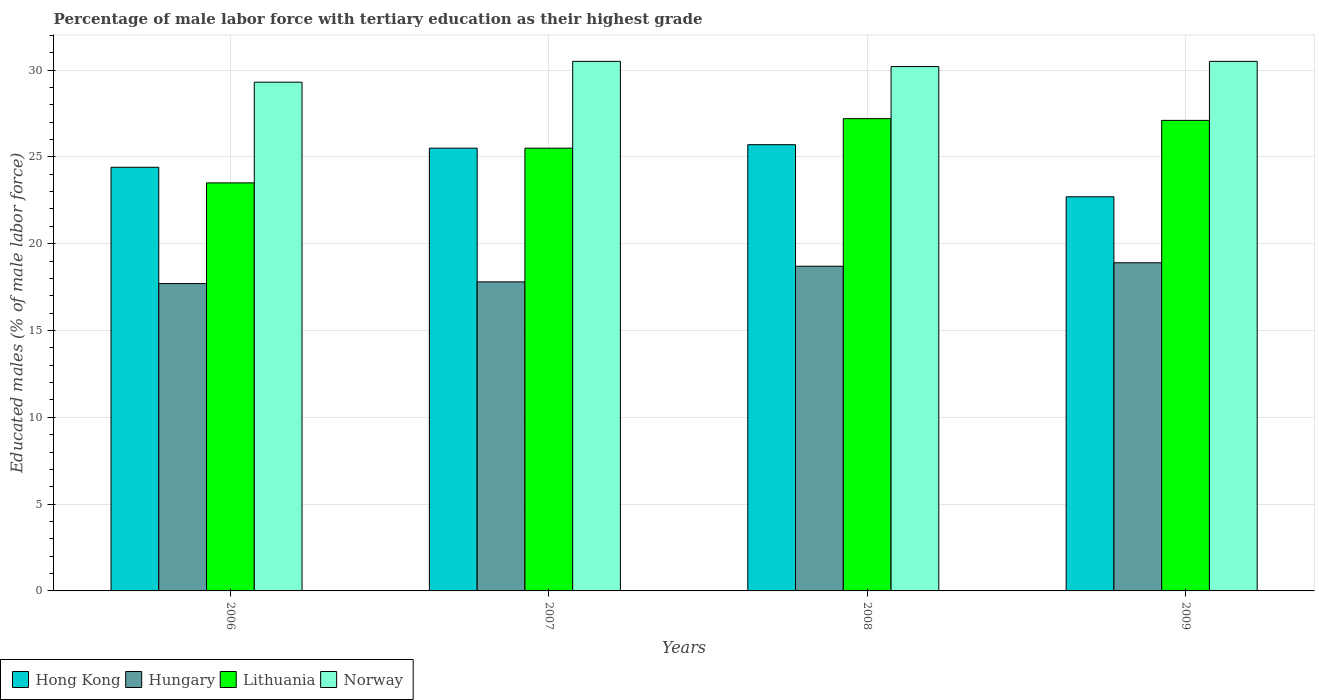How many groups of bars are there?
Offer a terse response. 4. Are the number of bars per tick equal to the number of legend labels?
Make the answer very short. Yes. How many bars are there on the 2nd tick from the left?
Give a very brief answer. 4. How many bars are there on the 3rd tick from the right?
Offer a very short reply. 4. What is the label of the 3rd group of bars from the left?
Make the answer very short. 2008. What is the percentage of male labor force with tertiary education in Hungary in 2006?
Keep it short and to the point. 17.7. Across all years, what is the maximum percentage of male labor force with tertiary education in Lithuania?
Your answer should be compact. 27.2. Across all years, what is the minimum percentage of male labor force with tertiary education in Norway?
Provide a succinct answer. 29.3. What is the total percentage of male labor force with tertiary education in Hong Kong in the graph?
Keep it short and to the point. 98.3. What is the difference between the percentage of male labor force with tertiary education in Lithuania in 2006 and that in 2009?
Your answer should be very brief. -3.6. What is the difference between the percentage of male labor force with tertiary education in Lithuania in 2008 and the percentage of male labor force with tertiary education in Hungary in 2007?
Your answer should be very brief. 9.4. What is the average percentage of male labor force with tertiary education in Hong Kong per year?
Make the answer very short. 24.58. In the year 2009, what is the difference between the percentage of male labor force with tertiary education in Lithuania and percentage of male labor force with tertiary education in Hungary?
Ensure brevity in your answer.  8.2. In how many years, is the percentage of male labor force with tertiary education in Hungary greater than 24 %?
Your answer should be compact. 0. What is the ratio of the percentage of male labor force with tertiary education in Norway in 2006 to that in 2009?
Your answer should be compact. 0.96. Is the difference between the percentage of male labor force with tertiary education in Lithuania in 2008 and 2009 greater than the difference between the percentage of male labor force with tertiary education in Hungary in 2008 and 2009?
Offer a terse response. Yes. What is the difference between the highest and the second highest percentage of male labor force with tertiary education in Hong Kong?
Make the answer very short. 0.2. What is the difference between the highest and the lowest percentage of male labor force with tertiary education in Lithuania?
Keep it short and to the point. 3.7. In how many years, is the percentage of male labor force with tertiary education in Lithuania greater than the average percentage of male labor force with tertiary education in Lithuania taken over all years?
Your answer should be very brief. 2. What does the 2nd bar from the left in 2007 represents?
Keep it short and to the point. Hungary. How many bars are there?
Your answer should be very brief. 16. How many years are there in the graph?
Provide a succinct answer. 4. Are the values on the major ticks of Y-axis written in scientific E-notation?
Offer a very short reply. No. Does the graph contain any zero values?
Give a very brief answer. No. Does the graph contain grids?
Offer a very short reply. Yes. How are the legend labels stacked?
Give a very brief answer. Horizontal. What is the title of the graph?
Provide a succinct answer. Percentage of male labor force with tertiary education as their highest grade. What is the label or title of the X-axis?
Provide a short and direct response. Years. What is the label or title of the Y-axis?
Make the answer very short. Educated males (% of male labor force). What is the Educated males (% of male labor force) in Hong Kong in 2006?
Your answer should be very brief. 24.4. What is the Educated males (% of male labor force) of Hungary in 2006?
Give a very brief answer. 17.7. What is the Educated males (% of male labor force) of Norway in 2006?
Keep it short and to the point. 29.3. What is the Educated males (% of male labor force) of Hungary in 2007?
Give a very brief answer. 17.8. What is the Educated males (% of male labor force) in Norway in 2007?
Your answer should be compact. 30.5. What is the Educated males (% of male labor force) of Hong Kong in 2008?
Ensure brevity in your answer.  25.7. What is the Educated males (% of male labor force) in Hungary in 2008?
Provide a succinct answer. 18.7. What is the Educated males (% of male labor force) of Lithuania in 2008?
Give a very brief answer. 27.2. What is the Educated males (% of male labor force) in Norway in 2008?
Give a very brief answer. 30.2. What is the Educated males (% of male labor force) of Hong Kong in 2009?
Offer a very short reply. 22.7. What is the Educated males (% of male labor force) of Hungary in 2009?
Provide a succinct answer. 18.9. What is the Educated males (% of male labor force) of Lithuania in 2009?
Give a very brief answer. 27.1. What is the Educated males (% of male labor force) in Norway in 2009?
Your answer should be very brief. 30.5. Across all years, what is the maximum Educated males (% of male labor force) of Hong Kong?
Give a very brief answer. 25.7. Across all years, what is the maximum Educated males (% of male labor force) of Hungary?
Provide a short and direct response. 18.9. Across all years, what is the maximum Educated males (% of male labor force) in Lithuania?
Make the answer very short. 27.2. Across all years, what is the maximum Educated males (% of male labor force) of Norway?
Keep it short and to the point. 30.5. Across all years, what is the minimum Educated males (% of male labor force) in Hong Kong?
Provide a short and direct response. 22.7. Across all years, what is the minimum Educated males (% of male labor force) of Hungary?
Give a very brief answer. 17.7. Across all years, what is the minimum Educated males (% of male labor force) of Norway?
Your response must be concise. 29.3. What is the total Educated males (% of male labor force) in Hong Kong in the graph?
Provide a succinct answer. 98.3. What is the total Educated males (% of male labor force) of Hungary in the graph?
Your answer should be very brief. 73.1. What is the total Educated males (% of male labor force) in Lithuania in the graph?
Offer a very short reply. 103.3. What is the total Educated males (% of male labor force) in Norway in the graph?
Offer a terse response. 120.5. What is the difference between the Educated males (% of male labor force) of Hong Kong in 2006 and that in 2007?
Provide a short and direct response. -1.1. What is the difference between the Educated males (% of male labor force) of Hungary in 2006 and that in 2007?
Keep it short and to the point. -0.1. What is the difference between the Educated males (% of male labor force) in Hong Kong in 2006 and that in 2008?
Make the answer very short. -1.3. What is the difference between the Educated males (% of male labor force) in Hungary in 2006 and that in 2008?
Your answer should be compact. -1. What is the difference between the Educated males (% of male labor force) in Norway in 2006 and that in 2008?
Make the answer very short. -0.9. What is the difference between the Educated males (% of male labor force) in Hong Kong in 2006 and that in 2009?
Your answer should be compact. 1.7. What is the difference between the Educated males (% of male labor force) of Hungary in 2006 and that in 2009?
Your answer should be compact. -1.2. What is the difference between the Educated males (% of male labor force) of Lithuania in 2006 and that in 2009?
Give a very brief answer. -3.6. What is the difference between the Educated males (% of male labor force) of Hong Kong in 2007 and that in 2009?
Give a very brief answer. 2.8. What is the difference between the Educated males (% of male labor force) in Hungary in 2008 and that in 2009?
Offer a very short reply. -0.2. What is the difference between the Educated males (% of male labor force) in Lithuania in 2008 and that in 2009?
Your response must be concise. 0.1. What is the difference between the Educated males (% of male labor force) in Hong Kong in 2006 and the Educated males (% of male labor force) in Lithuania in 2007?
Offer a terse response. -1.1. What is the difference between the Educated males (% of male labor force) of Hungary in 2006 and the Educated males (% of male labor force) of Lithuania in 2007?
Keep it short and to the point. -7.8. What is the difference between the Educated males (% of male labor force) of Hungary in 2006 and the Educated males (% of male labor force) of Norway in 2007?
Provide a short and direct response. -12.8. What is the difference between the Educated males (% of male labor force) of Lithuania in 2006 and the Educated males (% of male labor force) of Norway in 2007?
Make the answer very short. -7. What is the difference between the Educated males (% of male labor force) of Hong Kong in 2006 and the Educated males (% of male labor force) of Norway in 2008?
Provide a succinct answer. -5.8. What is the difference between the Educated males (% of male labor force) of Hungary in 2006 and the Educated males (% of male labor force) of Lithuania in 2008?
Ensure brevity in your answer.  -9.5. What is the difference between the Educated males (% of male labor force) of Hungary in 2006 and the Educated males (% of male labor force) of Norway in 2008?
Your answer should be very brief. -12.5. What is the difference between the Educated males (% of male labor force) of Hong Kong in 2006 and the Educated males (% of male labor force) of Hungary in 2009?
Your response must be concise. 5.5. What is the difference between the Educated males (% of male labor force) in Lithuania in 2006 and the Educated males (% of male labor force) in Norway in 2009?
Provide a short and direct response. -7. What is the difference between the Educated males (% of male labor force) of Hungary in 2007 and the Educated males (% of male labor force) of Lithuania in 2008?
Ensure brevity in your answer.  -9.4. What is the difference between the Educated males (% of male labor force) of Hungary in 2007 and the Educated males (% of male labor force) of Norway in 2008?
Your answer should be very brief. -12.4. What is the difference between the Educated males (% of male labor force) in Hungary in 2007 and the Educated males (% of male labor force) in Lithuania in 2009?
Provide a short and direct response. -9.3. What is the difference between the Educated males (% of male labor force) in Hungary in 2007 and the Educated males (% of male labor force) in Norway in 2009?
Provide a succinct answer. -12.7. What is the difference between the Educated males (% of male labor force) of Hungary in 2008 and the Educated males (% of male labor force) of Lithuania in 2009?
Give a very brief answer. -8.4. What is the difference between the Educated males (% of male labor force) in Hungary in 2008 and the Educated males (% of male labor force) in Norway in 2009?
Keep it short and to the point. -11.8. What is the average Educated males (% of male labor force) in Hong Kong per year?
Your answer should be very brief. 24.57. What is the average Educated males (% of male labor force) in Hungary per year?
Make the answer very short. 18.27. What is the average Educated males (% of male labor force) in Lithuania per year?
Keep it short and to the point. 25.82. What is the average Educated males (% of male labor force) in Norway per year?
Keep it short and to the point. 30.12. In the year 2006, what is the difference between the Educated males (% of male labor force) of Hong Kong and Educated males (% of male labor force) of Hungary?
Ensure brevity in your answer.  6.7. In the year 2006, what is the difference between the Educated males (% of male labor force) in Hong Kong and Educated males (% of male labor force) in Lithuania?
Keep it short and to the point. 0.9. In the year 2006, what is the difference between the Educated males (% of male labor force) in Hong Kong and Educated males (% of male labor force) in Norway?
Provide a succinct answer. -4.9. In the year 2006, what is the difference between the Educated males (% of male labor force) in Hungary and Educated males (% of male labor force) in Lithuania?
Provide a short and direct response. -5.8. In the year 2006, what is the difference between the Educated males (% of male labor force) of Hungary and Educated males (% of male labor force) of Norway?
Keep it short and to the point. -11.6. In the year 2007, what is the difference between the Educated males (% of male labor force) in Hong Kong and Educated males (% of male labor force) in Hungary?
Provide a succinct answer. 7.7. In the year 2007, what is the difference between the Educated males (% of male labor force) in Hong Kong and Educated males (% of male labor force) in Lithuania?
Provide a short and direct response. 0. In the year 2007, what is the difference between the Educated males (% of male labor force) in Hungary and Educated males (% of male labor force) in Lithuania?
Your answer should be compact. -7.7. In the year 2007, what is the difference between the Educated males (% of male labor force) of Hungary and Educated males (% of male labor force) of Norway?
Keep it short and to the point. -12.7. In the year 2007, what is the difference between the Educated males (% of male labor force) of Lithuania and Educated males (% of male labor force) of Norway?
Give a very brief answer. -5. In the year 2008, what is the difference between the Educated males (% of male labor force) of Hong Kong and Educated males (% of male labor force) of Hungary?
Give a very brief answer. 7. In the year 2008, what is the difference between the Educated males (% of male labor force) of Hong Kong and Educated males (% of male labor force) of Norway?
Offer a terse response. -4.5. In the year 2008, what is the difference between the Educated males (% of male labor force) of Hungary and Educated males (% of male labor force) of Norway?
Make the answer very short. -11.5. In the year 2008, what is the difference between the Educated males (% of male labor force) in Lithuania and Educated males (% of male labor force) in Norway?
Your answer should be compact. -3. In the year 2009, what is the difference between the Educated males (% of male labor force) in Hong Kong and Educated males (% of male labor force) in Norway?
Offer a very short reply. -7.8. In the year 2009, what is the difference between the Educated males (% of male labor force) in Hungary and Educated males (% of male labor force) in Lithuania?
Provide a short and direct response. -8.2. What is the ratio of the Educated males (% of male labor force) in Hong Kong in 2006 to that in 2007?
Ensure brevity in your answer.  0.96. What is the ratio of the Educated males (% of male labor force) in Lithuania in 2006 to that in 2007?
Offer a terse response. 0.92. What is the ratio of the Educated males (% of male labor force) in Norway in 2006 to that in 2007?
Your response must be concise. 0.96. What is the ratio of the Educated males (% of male labor force) of Hong Kong in 2006 to that in 2008?
Your response must be concise. 0.95. What is the ratio of the Educated males (% of male labor force) of Hungary in 2006 to that in 2008?
Keep it short and to the point. 0.95. What is the ratio of the Educated males (% of male labor force) in Lithuania in 2006 to that in 2008?
Offer a terse response. 0.86. What is the ratio of the Educated males (% of male labor force) of Norway in 2006 to that in 2008?
Your response must be concise. 0.97. What is the ratio of the Educated males (% of male labor force) of Hong Kong in 2006 to that in 2009?
Provide a short and direct response. 1.07. What is the ratio of the Educated males (% of male labor force) of Hungary in 2006 to that in 2009?
Your answer should be compact. 0.94. What is the ratio of the Educated males (% of male labor force) of Lithuania in 2006 to that in 2009?
Give a very brief answer. 0.87. What is the ratio of the Educated males (% of male labor force) of Norway in 2006 to that in 2009?
Your answer should be very brief. 0.96. What is the ratio of the Educated males (% of male labor force) of Hungary in 2007 to that in 2008?
Your answer should be very brief. 0.95. What is the ratio of the Educated males (% of male labor force) in Norway in 2007 to that in 2008?
Make the answer very short. 1.01. What is the ratio of the Educated males (% of male labor force) of Hong Kong in 2007 to that in 2009?
Offer a very short reply. 1.12. What is the ratio of the Educated males (% of male labor force) in Hungary in 2007 to that in 2009?
Make the answer very short. 0.94. What is the ratio of the Educated males (% of male labor force) in Lithuania in 2007 to that in 2009?
Offer a very short reply. 0.94. What is the ratio of the Educated males (% of male labor force) of Hong Kong in 2008 to that in 2009?
Keep it short and to the point. 1.13. What is the ratio of the Educated males (% of male labor force) of Norway in 2008 to that in 2009?
Offer a very short reply. 0.99. What is the difference between the highest and the second highest Educated males (% of male labor force) of Hong Kong?
Your answer should be compact. 0.2. What is the difference between the highest and the second highest Educated males (% of male labor force) of Hungary?
Offer a very short reply. 0.2. What is the difference between the highest and the lowest Educated males (% of male labor force) in Hong Kong?
Make the answer very short. 3. What is the difference between the highest and the lowest Educated males (% of male labor force) in Norway?
Provide a succinct answer. 1.2. 